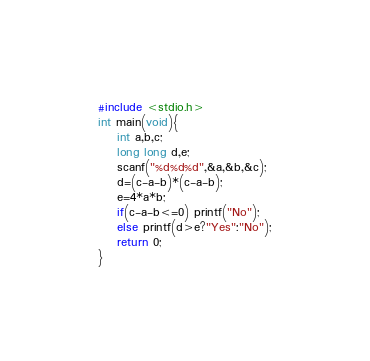<code> <loc_0><loc_0><loc_500><loc_500><_C_>#include <stdio.h>
int main(void){
	int a,b,c;
	long long d,e;
	scanf("%d%d%d",&a,&b,&c);
	d=(c-a-b)*(c-a-b);
	e=4*a*b;
	if(c-a-b<=0) printf("No");
	else printf(d>e?"Yes":"No");
	return 0;
}</code> 